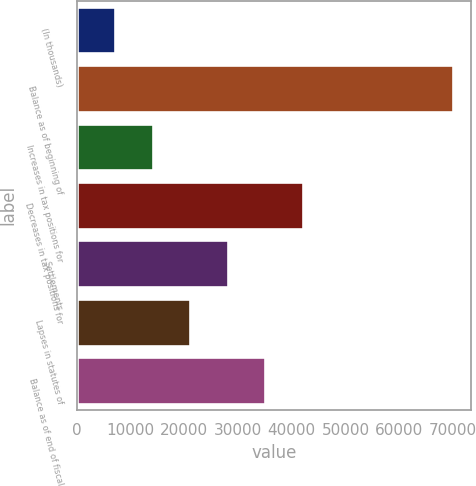<chart> <loc_0><loc_0><loc_500><loc_500><bar_chart><fcel>(In thousands)<fcel>Balance as of beginning of<fcel>Increases in tax positions for<fcel>Decreases in tax positions for<fcel>Settlements<fcel>Lapses in statutes of<fcel>Balance as of end of fiscal<nl><fcel>7142.4<fcel>69957<fcel>14121.8<fcel>42039.4<fcel>28080.6<fcel>21101.2<fcel>35060<nl></chart> 